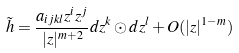Convert formula to latex. <formula><loc_0><loc_0><loc_500><loc_500>\tilde { h } = \frac { a _ { i j k l } z ^ { i } z ^ { j } } { | z | ^ { m + 2 } } d z ^ { k } \odot d z ^ { l } + O ( | z | ^ { 1 - m } )</formula> 